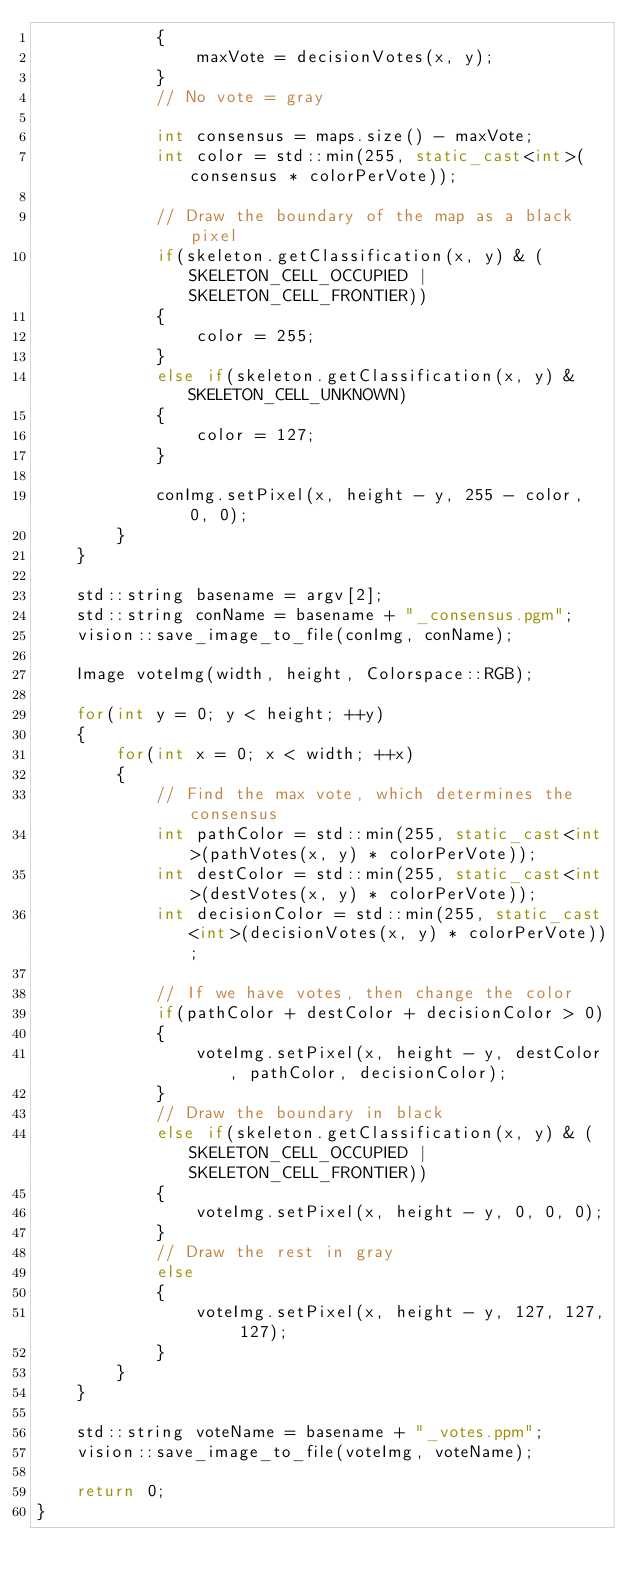Convert code to text. <code><loc_0><loc_0><loc_500><loc_500><_C++_>            {
                maxVote = decisionVotes(x, y);
            }
            // No vote = gray

            int consensus = maps.size() - maxVote;
            int color = std::min(255, static_cast<int>(consensus * colorPerVote));

            // Draw the boundary of the map as a black pixel
            if(skeleton.getClassification(x, y) & (SKELETON_CELL_OCCUPIED | SKELETON_CELL_FRONTIER))
            {
                color = 255;
            }
            else if(skeleton.getClassification(x, y) & SKELETON_CELL_UNKNOWN)
            {
                color = 127;
            }

            conImg.setPixel(x, height - y, 255 - color, 0, 0);
        }
    }

    std::string basename = argv[2];
    std::string conName = basename + "_consensus.pgm";
    vision::save_image_to_file(conImg, conName);

    Image voteImg(width, height, Colorspace::RGB);

    for(int y = 0; y < height; ++y)
    {
        for(int x = 0; x < width; ++x)
        {
            // Find the max vote, which determines the consensus
            int pathColor = std::min(255, static_cast<int>(pathVotes(x, y) * colorPerVote));
            int destColor = std::min(255, static_cast<int>(destVotes(x, y) * colorPerVote));
            int decisionColor = std::min(255, static_cast<int>(decisionVotes(x, y) * colorPerVote));

            // If we have votes, then change the color
            if(pathColor + destColor + decisionColor > 0)
            {
                voteImg.setPixel(x, height - y, destColor, pathColor, decisionColor);
            }
            // Draw the boundary in black
            else if(skeleton.getClassification(x, y) & (SKELETON_CELL_OCCUPIED | SKELETON_CELL_FRONTIER))
            {
                voteImg.setPixel(x, height - y, 0, 0, 0);
            }
            // Draw the rest in gray
            else
            {
                voteImg.setPixel(x, height - y, 127, 127, 127);
            }
        }
    }

    std::string voteName = basename + "_votes.ppm";
    vision::save_image_to_file(voteImg, voteName);

    return 0;
}
</code> 